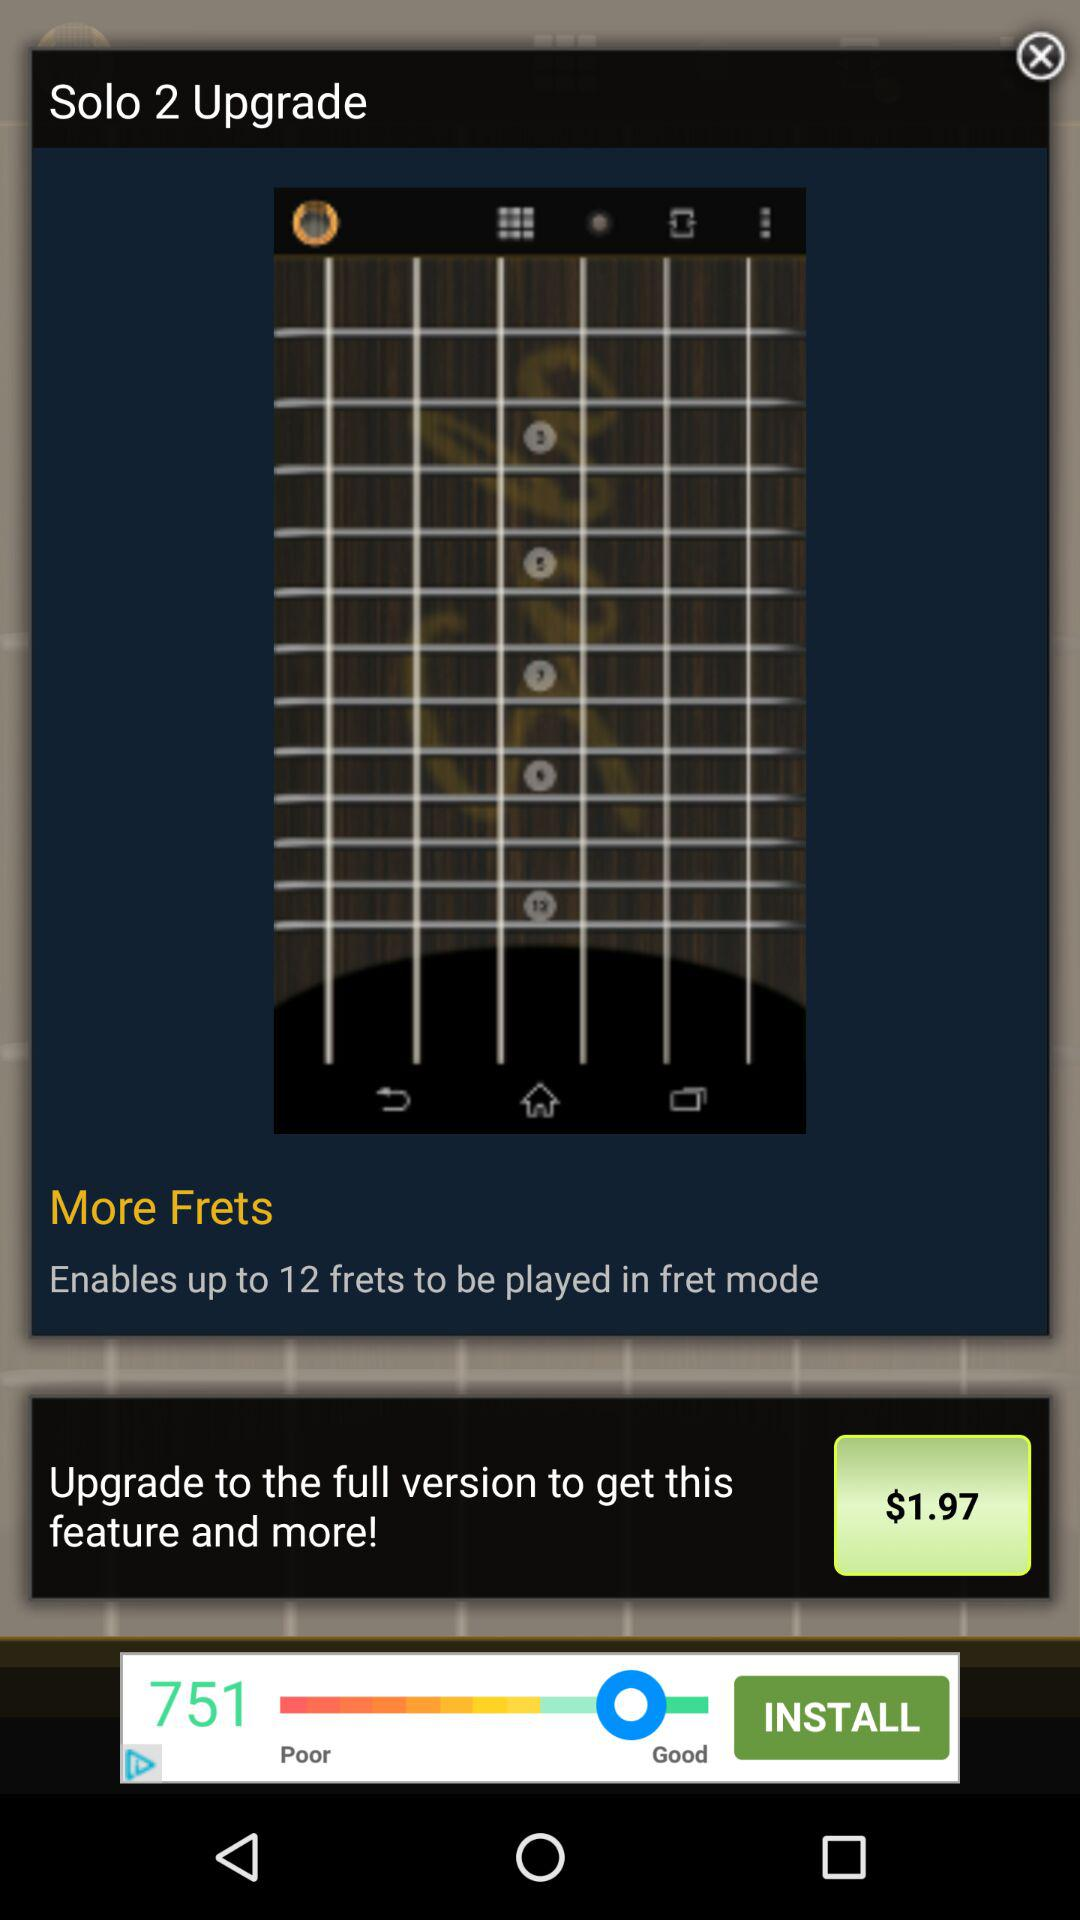How many frets does the full version of the app allow you to play?
Answer the question using a single word or phrase. 12 